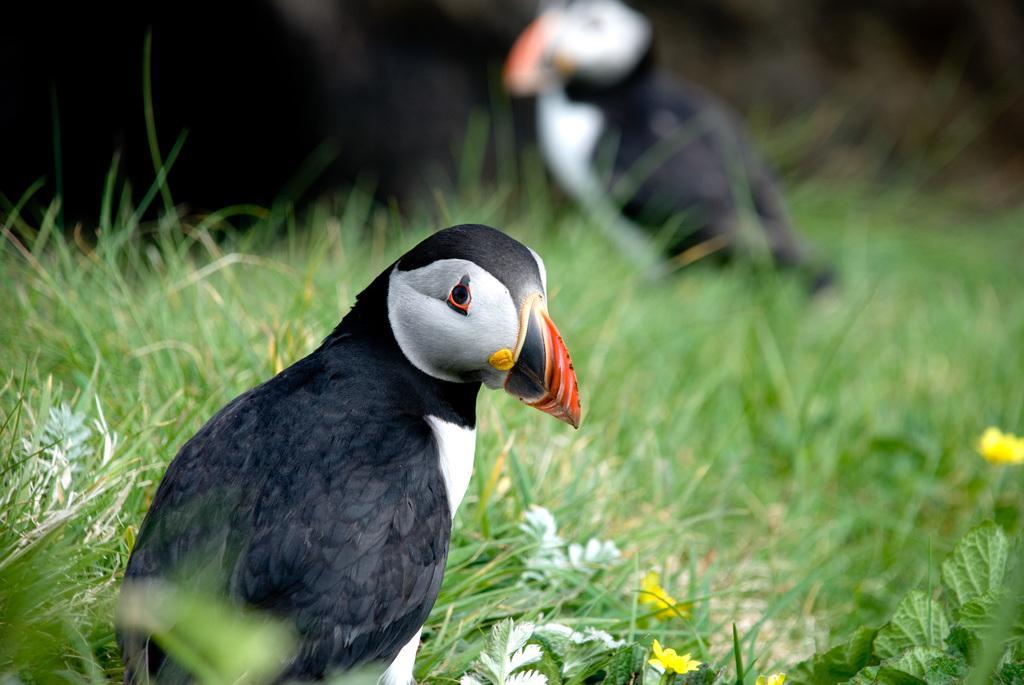Please provide a concise description of this image. In this picture we can see a bird. There are a few flowers and some grass is visible on the ground from left to right. We can see another bird in the background. Background is blurry. 